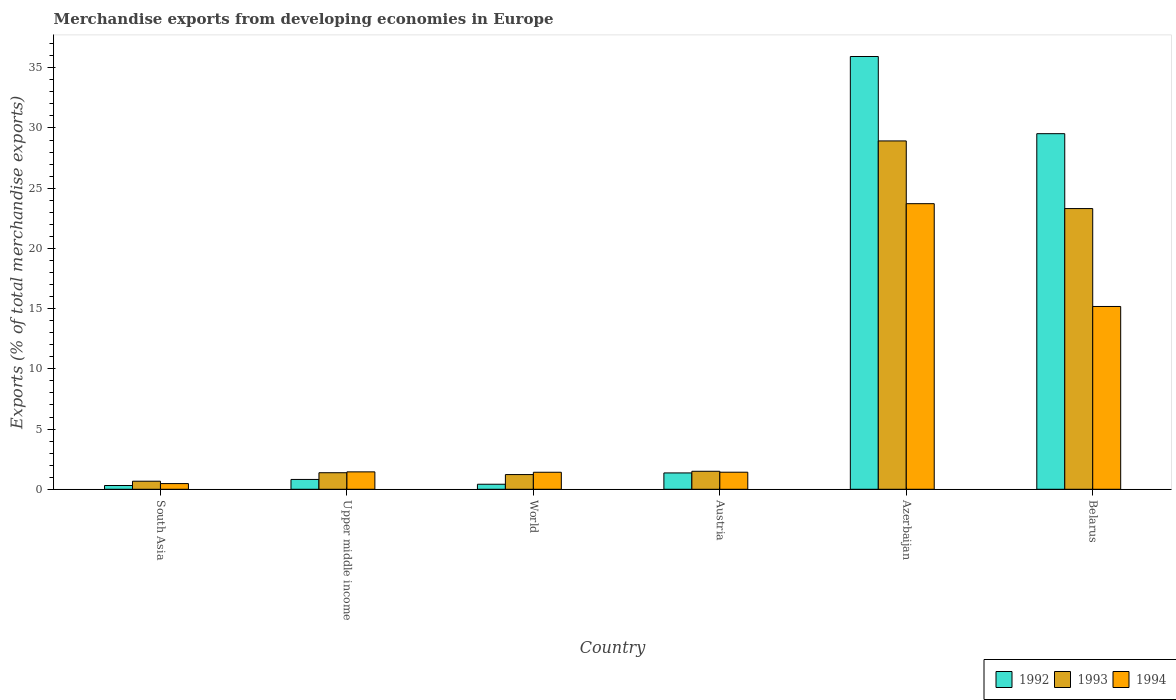Are the number of bars on each tick of the X-axis equal?
Offer a very short reply. Yes. How many bars are there on the 6th tick from the left?
Your response must be concise. 3. What is the label of the 6th group of bars from the left?
Keep it short and to the point. Belarus. In how many cases, is the number of bars for a given country not equal to the number of legend labels?
Make the answer very short. 0. What is the percentage of total merchandise exports in 1992 in World?
Your answer should be compact. 0.42. Across all countries, what is the maximum percentage of total merchandise exports in 1992?
Provide a succinct answer. 35.94. Across all countries, what is the minimum percentage of total merchandise exports in 1993?
Give a very brief answer. 0.67. In which country was the percentage of total merchandise exports in 1992 maximum?
Make the answer very short. Azerbaijan. In which country was the percentage of total merchandise exports in 1992 minimum?
Your answer should be compact. South Asia. What is the total percentage of total merchandise exports in 1993 in the graph?
Your answer should be compact. 57. What is the difference between the percentage of total merchandise exports in 1993 in Austria and that in Azerbaijan?
Provide a succinct answer. -27.43. What is the difference between the percentage of total merchandise exports in 1992 in Belarus and the percentage of total merchandise exports in 1993 in Austria?
Your answer should be compact. 28.03. What is the average percentage of total merchandise exports in 1993 per country?
Provide a succinct answer. 9.5. What is the difference between the percentage of total merchandise exports of/in 1994 and percentage of total merchandise exports of/in 1992 in Austria?
Give a very brief answer. 0.06. What is the ratio of the percentage of total merchandise exports in 1992 in Austria to that in South Asia?
Provide a short and direct response. 4.34. Is the percentage of total merchandise exports in 1992 in Austria less than that in Belarus?
Your response must be concise. Yes. What is the difference between the highest and the second highest percentage of total merchandise exports in 1992?
Offer a very short reply. -34.58. What is the difference between the highest and the lowest percentage of total merchandise exports in 1993?
Give a very brief answer. 28.26. What does the 3rd bar from the left in World represents?
Offer a very short reply. 1994. Is it the case that in every country, the sum of the percentage of total merchandise exports in 1994 and percentage of total merchandise exports in 1993 is greater than the percentage of total merchandise exports in 1992?
Give a very brief answer. Yes. How many bars are there?
Offer a terse response. 18. Are all the bars in the graph horizontal?
Provide a succinct answer. No. Are the values on the major ticks of Y-axis written in scientific E-notation?
Make the answer very short. No. Does the graph contain any zero values?
Make the answer very short. No. Where does the legend appear in the graph?
Offer a very short reply. Bottom right. How are the legend labels stacked?
Offer a very short reply. Horizontal. What is the title of the graph?
Keep it short and to the point. Merchandise exports from developing economies in Europe. Does "2008" appear as one of the legend labels in the graph?
Your response must be concise. No. What is the label or title of the Y-axis?
Ensure brevity in your answer.  Exports (% of total merchandise exports). What is the Exports (% of total merchandise exports) of 1992 in South Asia?
Make the answer very short. 0.31. What is the Exports (% of total merchandise exports) of 1993 in South Asia?
Make the answer very short. 0.67. What is the Exports (% of total merchandise exports) of 1994 in South Asia?
Give a very brief answer. 0.47. What is the Exports (% of total merchandise exports) of 1992 in Upper middle income?
Your answer should be very brief. 0.82. What is the Exports (% of total merchandise exports) of 1993 in Upper middle income?
Offer a terse response. 1.37. What is the Exports (% of total merchandise exports) in 1994 in Upper middle income?
Offer a very short reply. 1.45. What is the Exports (% of total merchandise exports) in 1992 in World?
Your answer should be compact. 0.42. What is the Exports (% of total merchandise exports) of 1993 in World?
Your response must be concise. 1.22. What is the Exports (% of total merchandise exports) in 1994 in World?
Offer a terse response. 1.41. What is the Exports (% of total merchandise exports) of 1992 in Austria?
Your response must be concise. 1.36. What is the Exports (% of total merchandise exports) in 1993 in Austria?
Your answer should be compact. 1.49. What is the Exports (% of total merchandise exports) of 1994 in Austria?
Ensure brevity in your answer.  1.42. What is the Exports (% of total merchandise exports) of 1992 in Azerbaijan?
Your response must be concise. 35.94. What is the Exports (% of total merchandise exports) of 1993 in Azerbaijan?
Ensure brevity in your answer.  28.93. What is the Exports (% of total merchandise exports) in 1994 in Azerbaijan?
Your answer should be very brief. 23.72. What is the Exports (% of total merchandise exports) of 1992 in Belarus?
Your response must be concise. 29.53. What is the Exports (% of total merchandise exports) in 1993 in Belarus?
Give a very brief answer. 23.31. What is the Exports (% of total merchandise exports) of 1994 in Belarus?
Offer a very short reply. 15.18. Across all countries, what is the maximum Exports (% of total merchandise exports) in 1992?
Your answer should be very brief. 35.94. Across all countries, what is the maximum Exports (% of total merchandise exports) of 1993?
Ensure brevity in your answer.  28.93. Across all countries, what is the maximum Exports (% of total merchandise exports) of 1994?
Your response must be concise. 23.72. Across all countries, what is the minimum Exports (% of total merchandise exports) of 1992?
Ensure brevity in your answer.  0.31. Across all countries, what is the minimum Exports (% of total merchandise exports) in 1993?
Your answer should be compact. 0.67. Across all countries, what is the minimum Exports (% of total merchandise exports) in 1994?
Provide a short and direct response. 0.47. What is the total Exports (% of total merchandise exports) in 1992 in the graph?
Offer a very short reply. 68.37. What is the total Exports (% of total merchandise exports) of 1993 in the graph?
Keep it short and to the point. 57. What is the total Exports (% of total merchandise exports) in 1994 in the graph?
Provide a short and direct response. 43.64. What is the difference between the Exports (% of total merchandise exports) of 1992 in South Asia and that in Upper middle income?
Make the answer very short. -0.5. What is the difference between the Exports (% of total merchandise exports) in 1993 in South Asia and that in Upper middle income?
Provide a succinct answer. -0.7. What is the difference between the Exports (% of total merchandise exports) in 1994 in South Asia and that in Upper middle income?
Your answer should be compact. -0.97. What is the difference between the Exports (% of total merchandise exports) in 1992 in South Asia and that in World?
Make the answer very short. -0.11. What is the difference between the Exports (% of total merchandise exports) in 1993 in South Asia and that in World?
Make the answer very short. -0.55. What is the difference between the Exports (% of total merchandise exports) in 1994 in South Asia and that in World?
Keep it short and to the point. -0.94. What is the difference between the Exports (% of total merchandise exports) in 1992 in South Asia and that in Austria?
Make the answer very short. -1.04. What is the difference between the Exports (% of total merchandise exports) of 1993 in South Asia and that in Austria?
Ensure brevity in your answer.  -0.82. What is the difference between the Exports (% of total merchandise exports) in 1994 in South Asia and that in Austria?
Your answer should be compact. -0.94. What is the difference between the Exports (% of total merchandise exports) in 1992 in South Asia and that in Azerbaijan?
Keep it short and to the point. -35.62. What is the difference between the Exports (% of total merchandise exports) of 1993 in South Asia and that in Azerbaijan?
Keep it short and to the point. -28.26. What is the difference between the Exports (% of total merchandise exports) of 1994 in South Asia and that in Azerbaijan?
Provide a short and direct response. -23.24. What is the difference between the Exports (% of total merchandise exports) in 1992 in South Asia and that in Belarus?
Your response must be concise. -29.21. What is the difference between the Exports (% of total merchandise exports) of 1993 in South Asia and that in Belarus?
Provide a succinct answer. -22.64. What is the difference between the Exports (% of total merchandise exports) of 1994 in South Asia and that in Belarus?
Provide a succinct answer. -14.71. What is the difference between the Exports (% of total merchandise exports) of 1992 in Upper middle income and that in World?
Your response must be concise. 0.4. What is the difference between the Exports (% of total merchandise exports) of 1993 in Upper middle income and that in World?
Your answer should be compact. 0.15. What is the difference between the Exports (% of total merchandise exports) in 1994 in Upper middle income and that in World?
Your answer should be compact. 0.03. What is the difference between the Exports (% of total merchandise exports) of 1992 in Upper middle income and that in Austria?
Keep it short and to the point. -0.54. What is the difference between the Exports (% of total merchandise exports) in 1993 in Upper middle income and that in Austria?
Provide a short and direct response. -0.12. What is the difference between the Exports (% of total merchandise exports) of 1994 in Upper middle income and that in Austria?
Give a very brief answer. 0.03. What is the difference between the Exports (% of total merchandise exports) in 1992 in Upper middle income and that in Azerbaijan?
Make the answer very short. -35.12. What is the difference between the Exports (% of total merchandise exports) in 1993 in Upper middle income and that in Azerbaijan?
Your answer should be compact. -27.55. What is the difference between the Exports (% of total merchandise exports) of 1994 in Upper middle income and that in Azerbaijan?
Your response must be concise. -22.27. What is the difference between the Exports (% of total merchandise exports) in 1992 in Upper middle income and that in Belarus?
Keep it short and to the point. -28.71. What is the difference between the Exports (% of total merchandise exports) of 1993 in Upper middle income and that in Belarus?
Provide a succinct answer. -21.93. What is the difference between the Exports (% of total merchandise exports) of 1994 in Upper middle income and that in Belarus?
Your answer should be very brief. -13.73. What is the difference between the Exports (% of total merchandise exports) in 1992 in World and that in Austria?
Keep it short and to the point. -0.94. What is the difference between the Exports (% of total merchandise exports) of 1993 in World and that in Austria?
Make the answer very short. -0.27. What is the difference between the Exports (% of total merchandise exports) of 1994 in World and that in Austria?
Give a very brief answer. -0. What is the difference between the Exports (% of total merchandise exports) of 1992 in World and that in Azerbaijan?
Your answer should be very brief. -35.52. What is the difference between the Exports (% of total merchandise exports) of 1993 in World and that in Azerbaijan?
Offer a very short reply. -27.7. What is the difference between the Exports (% of total merchandise exports) of 1994 in World and that in Azerbaijan?
Your answer should be compact. -22.3. What is the difference between the Exports (% of total merchandise exports) of 1992 in World and that in Belarus?
Make the answer very short. -29.11. What is the difference between the Exports (% of total merchandise exports) of 1993 in World and that in Belarus?
Your response must be concise. -22.09. What is the difference between the Exports (% of total merchandise exports) of 1994 in World and that in Belarus?
Your response must be concise. -13.77. What is the difference between the Exports (% of total merchandise exports) in 1992 in Austria and that in Azerbaijan?
Keep it short and to the point. -34.58. What is the difference between the Exports (% of total merchandise exports) in 1993 in Austria and that in Azerbaijan?
Give a very brief answer. -27.43. What is the difference between the Exports (% of total merchandise exports) in 1994 in Austria and that in Azerbaijan?
Offer a terse response. -22.3. What is the difference between the Exports (% of total merchandise exports) in 1992 in Austria and that in Belarus?
Your response must be concise. -28.17. What is the difference between the Exports (% of total merchandise exports) of 1993 in Austria and that in Belarus?
Give a very brief answer. -21.81. What is the difference between the Exports (% of total merchandise exports) of 1994 in Austria and that in Belarus?
Offer a terse response. -13.76. What is the difference between the Exports (% of total merchandise exports) in 1992 in Azerbaijan and that in Belarus?
Give a very brief answer. 6.41. What is the difference between the Exports (% of total merchandise exports) of 1993 in Azerbaijan and that in Belarus?
Offer a terse response. 5.62. What is the difference between the Exports (% of total merchandise exports) of 1994 in Azerbaijan and that in Belarus?
Provide a succinct answer. 8.54. What is the difference between the Exports (% of total merchandise exports) of 1992 in South Asia and the Exports (% of total merchandise exports) of 1993 in Upper middle income?
Your answer should be very brief. -1.06. What is the difference between the Exports (% of total merchandise exports) of 1992 in South Asia and the Exports (% of total merchandise exports) of 1994 in Upper middle income?
Give a very brief answer. -1.13. What is the difference between the Exports (% of total merchandise exports) in 1993 in South Asia and the Exports (% of total merchandise exports) in 1994 in Upper middle income?
Your response must be concise. -0.78. What is the difference between the Exports (% of total merchandise exports) in 1992 in South Asia and the Exports (% of total merchandise exports) in 1993 in World?
Your answer should be compact. -0.91. What is the difference between the Exports (% of total merchandise exports) of 1992 in South Asia and the Exports (% of total merchandise exports) of 1994 in World?
Your response must be concise. -1.1. What is the difference between the Exports (% of total merchandise exports) of 1993 in South Asia and the Exports (% of total merchandise exports) of 1994 in World?
Your answer should be compact. -0.74. What is the difference between the Exports (% of total merchandise exports) of 1992 in South Asia and the Exports (% of total merchandise exports) of 1993 in Austria?
Provide a short and direct response. -1.18. What is the difference between the Exports (% of total merchandise exports) of 1992 in South Asia and the Exports (% of total merchandise exports) of 1994 in Austria?
Your answer should be very brief. -1.1. What is the difference between the Exports (% of total merchandise exports) in 1993 in South Asia and the Exports (% of total merchandise exports) in 1994 in Austria?
Provide a short and direct response. -0.75. What is the difference between the Exports (% of total merchandise exports) of 1992 in South Asia and the Exports (% of total merchandise exports) of 1993 in Azerbaijan?
Your response must be concise. -28.61. What is the difference between the Exports (% of total merchandise exports) in 1992 in South Asia and the Exports (% of total merchandise exports) in 1994 in Azerbaijan?
Provide a succinct answer. -23.4. What is the difference between the Exports (% of total merchandise exports) in 1993 in South Asia and the Exports (% of total merchandise exports) in 1994 in Azerbaijan?
Give a very brief answer. -23.05. What is the difference between the Exports (% of total merchandise exports) of 1992 in South Asia and the Exports (% of total merchandise exports) of 1993 in Belarus?
Ensure brevity in your answer.  -23. What is the difference between the Exports (% of total merchandise exports) of 1992 in South Asia and the Exports (% of total merchandise exports) of 1994 in Belarus?
Keep it short and to the point. -14.87. What is the difference between the Exports (% of total merchandise exports) in 1993 in South Asia and the Exports (% of total merchandise exports) in 1994 in Belarus?
Provide a short and direct response. -14.51. What is the difference between the Exports (% of total merchandise exports) of 1992 in Upper middle income and the Exports (% of total merchandise exports) of 1993 in World?
Your response must be concise. -0.41. What is the difference between the Exports (% of total merchandise exports) of 1992 in Upper middle income and the Exports (% of total merchandise exports) of 1994 in World?
Keep it short and to the point. -0.6. What is the difference between the Exports (% of total merchandise exports) in 1993 in Upper middle income and the Exports (% of total merchandise exports) in 1994 in World?
Your response must be concise. -0.04. What is the difference between the Exports (% of total merchandise exports) of 1992 in Upper middle income and the Exports (% of total merchandise exports) of 1993 in Austria?
Ensure brevity in your answer.  -0.68. What is the difference between the Exports (% of total merchandise exports) in 1992 in Upper middle income and the Exports (% of total merchandise exports) in 1994 in Austria?
Provide a succinct answer. -0.6. What is the difference between the Exports (% of total merchandise exports) in 1993 in Upper middle income and the Exports (% of total merchandise exports) in 1994 in Austria?
Your answer should be very brief. -0.04. What is the difference between the Exports (% of total merchandise exports) in 1992 in Upper middle income and the Exports (% of total merchandise exports) in 1993 in Azerbaijan?
Keep it short and to the point. -28.11. What is the difference between the Exports (% of total merchandise exports) in 1992 in Upper middle income and the Exports (% of total merchandise exports) in 1994 in Azerbaijan?
Ensure brevity in your answer.  -22.9. What is the difference between the Exports (% of total merchandise exports) of 1993 in Upper middle income and the Exports (% of total merchandise exports) of 1994 in Azerbaijan?
Your answer should be very brief. -22.34. What is the difference between the Exports (% of total merchandise exports) of 1992 in Upper middle income and the Exports (% of total merchandise exports) of 1993 in Belarus?
Make the answer very short. -22.49. What is the difference between the Exports (% of total merchandise exports) of 1992 in Upper middle income and the Exports (% of total merchandise exports) of 1994 in Belarus?
Make the answer very short. -14.36. What is the difference between the Exports (% of total merchandise exports) in 1993 in Upper middle income and the Exports (% of total merchandise exports) in 1994 in Belarus?
Ensure brevity in your answer.  -13.8. What is the difference between the Exports (% of total merchandise exports) of 1992 in World and the Exports (% of total merchandise exports) of 1993 in Austria?
Your response must be concise. -1.08. What is the difference between the Exports (% of total merchandise exports) in 1992 in World and the Exports (% of total merchandise exports) in 1994 in Austria?
Your response must be concise. -1. What is the difference between the Exports (% of total merchandise exports) of 1993 in World and the Exports (% of total merchandise exports) of 1994 in Austria?
Provide a succinct answer. -0.2. What is the difference between the Exports (% of total merchandise exports) in 1992 in World and the Exports (% of total merchandise exports) in 1993 in Azerbaijan?
Keep it short and to the point. -28.51. What is the difference between the Exports (% of total merchandise exports) of 1992 in World and the Exports (% of total merchandise exports) of 1994 in Azerbaijan?
Offer a terse response. -23.3. What is the difference between the Exports (% of total merchandise exports) of 1993 in World and the Exports (% of total merchandise exports) of 1994 in Azerbaijan?
Provide a succinct answer. -22.49. What is the difference between the Exports (% of total merchandise exports) of 1992 in World and the Exports (% of total merchandise exports) of 1993 in Belarus?
Your answer should be compact. -22.89. What is the difference between the Exports (% of total merchandise exports) in 1992 in World and the Exports (% of total merchandise exports) in 1994 in Belarus?
Your answer should be compact. -14.76. What is the difference between the Exports (% of total merchandise exports) in 1993 in World and the Exports (% of total merchandise exports) in 1994 in Belarus?
Provide a succinct answer. -13.96. What is the difference between the Exports (% of total merchandise exports) of 1992 in Austria and the Exports (% of total merchandise exports) of 1993 in Azerbaijan?
Offer a very short reply. -27.57. What is the difference between the Exports (% of total merchandise exports) in 1992 in Austria and the Exports (% of total merchandise exports) in 1994 in Azerbaijan?
Your answer should be very brief. -22.36. What is the difference between the Exports (% of total merchandise exports) in 1993 in Austria and the Exports (% of total merchandise exports) in 1994 in Azerbaijan?
Offer a terse response. -22.22. What is the difference between the Exports (% of total merchandise exports) in 1992 in Austria and the Exports (% of total merchandise exports) in 1993 in Belarus?
Ensure brevity in your answer.  -21.95. What is the difference between the Exports (% of total merchandise exports) of 1992 in Austria and the Exports (% of total merchandise exports) of 1994 in Belarus?
Your answer should be compact. -13.82. What is the difference between the Exports (% of total merchandise exports) in 1993 in Austria and the Exports (% of total merchandise exports) in 1994 in Belarus?
Offer a terse response. -13.68. What is the difference between the Exports (% of total merchandise exports) in 1992 in Azerbaijan and the Exports (% of total merchandise exports) in 1993 in Belarus?
Provide a short and direct response. 12.63. What is the difference between the Exports (% of total merchandise exports) in 1992 in Azerbaijan and the Exports (% of total merchandise exports) in 1994 in Belarus?
Offer a very short reply. 20.76. What is the difference between the Exports (% of total merchandise exports) in 1993 in Azerbaijan and the Exports (% of total merchandise exports) in 1994 in Belarus?
Make the answer very short. 13.75. What is the average Exports (% of total merchandise exports) of 1992 per country?
Keep it short and to the point. 11.39. What is the average Exports (% of total merchandise exports) in 1993 per country?
Your answer should be very brief. 9.5. What is the average Exports (% of total merchandise exports) in 1994 per country?
Make the answer very short. 7.27. What is the difference between the Exports (% of total merchandise exports) of 1992 and Exports (% of total merchandise exports) of 1993 in South Asia?
Your answer should be very brief. -0.36. What is the difference between the Exports (% of total merchandise exports) of 1992 and Exports (% of total merchandise exports) of 1994 in South Asia?
Your answer should be very brief. -0.16. What is the difference between the Exports (% of total merchandise exports) in 1993 and Exports (% of total merchandise exports) in 1994 in South Asia?
Your answer should be compact. 0.2. What is the difference between the Exports (% of total merchandise exports) in 1992 and Exports (% of total merchandise exports) in 1993 in Upper middle income?
Make the answer very short. -0.56. What is the difference between the Exports (% of total merchandise exports) of 1992 and Exports (% of total merchandise exports) of 1994 in Upper middle income?
Make the answer very short. -0.63. What is the difference between the Exports (% of total merchandise exports) in 1993 and Exports (% of total merchandise exports) in 1994 in Upper middle income?
Your response must be concise. -0.07. What is the difference between the Exports (% of total merchandise exports) in 1992 and Exports (% of total merchandise exports) in 1993 in World?
Make the answer very short. -0.8. What is the difference between the Exports (% of total merchandise exports) in 1992 and Exports (% of total merchandise exports) in 1994 in World?
Your answer should be compact. -0.99. What is the difference between the Exports (% of total merchandise exports) of 1993 and Exports (% of total merchandise exports) of 1994 in World?
Make the answer very short. -0.19. What is the difference between the Exports (% of total merchandise exports) of 1992 and Exports (% of total merchandise exports) of 1993 in Austria?
Give a very brief answer. -0.14. What is the difference between the Exports (% of total merchandise exports) in 1992 and Exports (% of total merchandise exports) in 1994 in Austria?
Your answer should be very brief. -0.06. What is the difference between the Exports (% of total merchandise exports) in 1993 and Exports (% of total merchandise exports) in 1994 in Austria?
Provide a short and direct response. 0.08. What is the difference between the Exports (% of total merchandise exports) of 1992 and Exports (% of total merchandise exports) of 1993 in Azerbaijan?
Make the answer very short. 7.01. What is the difference between the Exports (% of total merchandise exports) of 1992 and Exports (% of total merchandise exports) of 1994 in Azerbaijan?
Your answer should be compact. 12.22. What is the difference between the Exports (% of total merchandise exports) of 1993 and Exports (% of total merchandise exports) of 1994 in Azerbaijan?
Your answer should be compact. 5.21. What is the difference between the Exports (% of total merchandise exports) in 1992 and Exports (% of total merchandise exports) in 1993 in Belarus?
Make the answer very short. 6.22. What is the difference between the Exports (% of total merchandise exports) of 1992 and Exports (% of total merchandise exports) of 1994 in Belarus?
Make the answer very short. 14.35. What is the difference between the Exports (% of total merchandise exports) in 1993 and Exports (% of total merchandise exports) in 1994 in Belarus?
Your response must be concise. 8.13. What is the ratio of the Exports (% of total merchandise exports) of 1992 in South Asia to that in Upper middle income?
Give a very brief answer. 0.38. What is the ratio of the Exports (% of total merchandise exports) of 1993 in South Asia to that in Upper middle income?
Provide a succinct answer. 0.49. What is the ratio of the Exports (% of total merchandise exports) of 1994 in South Asia to that in Upper middle income?
Provide a succinct answer. 0.33. What is the ratio of the Exports (% of total merchandise exports) of 1992 in South Asia to that in World?
Provide a short and direct response. 0.75. What is the ratio of the Exports (% of total merchandise exports) of 1993 in South Asia to that in World?
Keep it short and to the point. 0.55. What is the ratio of the Exports (% of total merchandise exports) in 1994 in South Asia to that in World?
Keep it short and to the point. 0.33. What is the ratio of the Exports (% of total merchandise exports) in 1992 in South Asia to that in Austria?
Your answer should be compact. 0.23. What is the ratio of the Exports (% of total merchandise exports) of 1993 in South Asia to that in Austria?
Ensure brevity in your answer.  0.45. What is the ratio of the Exports (% of total merchandise exports) of 1994 in South Asia to that in Austria?
Offer a terse response. 0.33. What is the ratio of the Exports (% of total merchandise exports) in 1992 in South Asia to that in Azerbaijan?
Keep it short and to the point. 0.01. What is the ratio of the Exports (% of total merchandise exports) of 1993 in South Asia to that in Azerbaijan?
Your response must be concise. 0.02. What is the ratio of the Exports (% of total merchandise exports) of 1994 in South Asia to that in Azerbaijan?
Keep it short and to the point. 0.02. What is the ratio of the Exports (% of total merchandise exports) of 1992 in South Asia to that in Belarus?
Keep it short and to the point. 0.01. What is the ratio of the Exports (% of total merchandise exports) of 1993 in South Asia to that in Belarus?
Your answer should be compact. 0.03. What is the ratio of the Exports (% of total merchandise exports) of 1994 in South Asia to that in Belarus?
Offer a very short reply. 0.03. What is the ratio of the Exports (% of total merchandise exports) of 1992 in Upper middle income to that in World?
Offer a very short reply. 1.95. What is the ratio of the Exports (% of total merchandise exports) of 1993 in Upper middle income to that in World?
Provide a succinct answer. 1.13. What is the ratio of the Exports (% of total merchandise exports) in 1994 in Upper middle income to that in World?
Ensure brevity in your answer.  1.02. What is the ratio of the Exports (% of total merchandise exports) of 1992 in Upper middle income to that in Austria?
Your answer should be very brief. 0.6. What is the ratio of the Exports (% of total merchandise exports) in 1993 in Upper middle income to that in Austria?
Ensure brevity in your answer.  0.92. What is the ratio of the Exports (% of total merchandise exports) in 1994 in Upper middle income to that in Austria?
Your answer should be compact. 1.02. What is the ratio of the Exports (% of total merchandise exports) of 1992 in Upper middle income to that in Azerbaijan?
Provide a succinct answer. 0.02. What is the ratio of the Exports (% of total merchandise exports) of 1993 in Upper middle income to that in Azerbaijan?
Your answer should be very brief. 0.05. What is the ratio of the Exports (% of total merchandise exports) in 1994 in Upper middle income to that in Azerbaijan?
Keep it short and to the point. 0.06. What is the ratio of the Exports (% of total merchandise exports) in 1992 in Upper middle income to that in Belarus?
Provide a short and direct response. 0.03. What is the ratio of the Exports (% of total merchandise exports) of 1993 in Upper middle income to that in Belarus?
Your answer should be very brief. 0.06. What is the ratio of the Exports (% of total merchandise exports) of 1994 in Upper middle income to that in Belarus?
Provide a short and direct response. 0.1. What is the ratio of the Exports (% of total merchandise exports) in 1992 in World to that in Austria?
Provide a succinct answer. 0.31. What is the ratio of the Exports (% of total merchandise exports) in 1993 in World to that in Austria?
Offer a very short reply. 0.82. What is the ratio of the Exports (% of total merchandise exports) of 1992 in World to that in Azerbaijan?
Give a very brief answer. 0.01. What is the ratio of the Exports (% of total merchandise exports) of 1993 in World to that in Azerbaijan?
Make the answer very short. 0.04. What is the ratio of the Exports (% of total merchandise exports) of 1994 in World to that in Azerbaijan?
Give a very brief answer. 0.06. What is the ratio of the Exports (% of total merchandise exports) in 1992 in World to that in Belarus?
Your response must be concise. 0.01. What is the ratio of the Exports (% of total merchandise exports) of 1993 in World to that in Belarus?
Keep it short and to the point. 0.05. What is the ratio of the Exports (% of total merchandise exports) of 1994 in World to that in Belarus?
Offer a very short reply. 0.09. What is the ratio of the Exports (% of total merchandise exports) of 1992 in Austria to that in Azerbaijan?
Your answer should be compact. 0.04. What is the ratio of the Exports (% of total merchandise exports) of 1993 in Austria to that in Azerbaijan?
Your answer should be very brief. 0.05. What is the ratio of the Exports (% of total merchandise exports) of 1994 in Austria to that in Azerbaijan?
Make the answer very short. 0.06. What is the ratio of the Exports (% of total merchandise exports) in 1992 in Austria to that in Belarus?
Provide a succinct answer. 0.05. What is the ratio of the Exports (% of total merchandise exports) in 1993 in Austria to that in Belarus?
Offer a very short reply. 0.06. What is the ratio of the Exports (% of total merchandise exports) in 1994 in Austria to that in Belarus?
Your response must be concise. 0.09. What is the ratio of the Exports (% of total merchandise exports) in 1992 in Azerbaijan to that in Belarus?
Provide a succinct answer. 1.22. What is the ratio of the Exports (% of total merchandise exports) in 1993 in Azerbaijan to that in Belarus?
Offer a very short reply. 1.24. What is the ratio of the Exports (% of total merchandise exports) of 1994 in Azerbaijan to that in Belarus?
Your answer should be compact. 1.56. What is the difference between the highest and the second highest Exports (% of total merchandise exports) of 1992?
Keep it short and to the point. 6.41. What is the difference between the highest and the second highest Exports (% of total merchandise exports) of 1993?
Offer a terse response. 5.62. What is the difference between the highest and the second highest Exports (% of total merchandise exports) of 1994?
Give a very brief answer. 8.54. What is the difference between the highest and the lowest Exports (% of total merchandise exports) in 1992?
Offer a terse response. 35.62. What is the difference between the highest and the lowest Exports (% of total merchandise exports) of 1993?
Offer a very short reply. 28.26. What is the difference between the highest and the lowest Exports (% of total merchandise exports) of 1994?
Your answer should be compact. 23.24. 